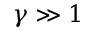<formula> <loc_0><loc_0><loc_500><loc_500>\gamma \gg 1</formula> 